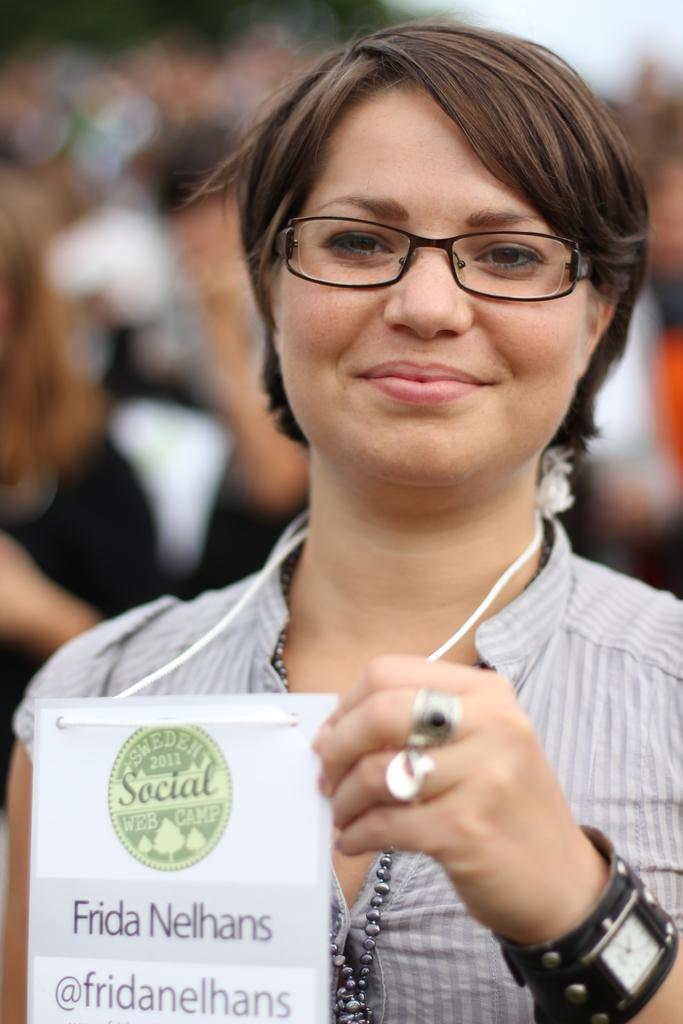What is the main subject of the image? There is a person in the image. Can you describe the person's attire? The person is wearing an ash-colored dress. What accessory is the person wearing? The person is wearing specs. What is the person holding in the image? The person is holding a card. What can be seen in the background of the image? There is a group of people in the people in the background of the image, but they are blurry. What type of hen can be seen in the image? There is no hen present in the image. How does the zephyr affect the person's hair in the image? There is no mention of a zephyr or any wind affecting the person's hair in the image. 